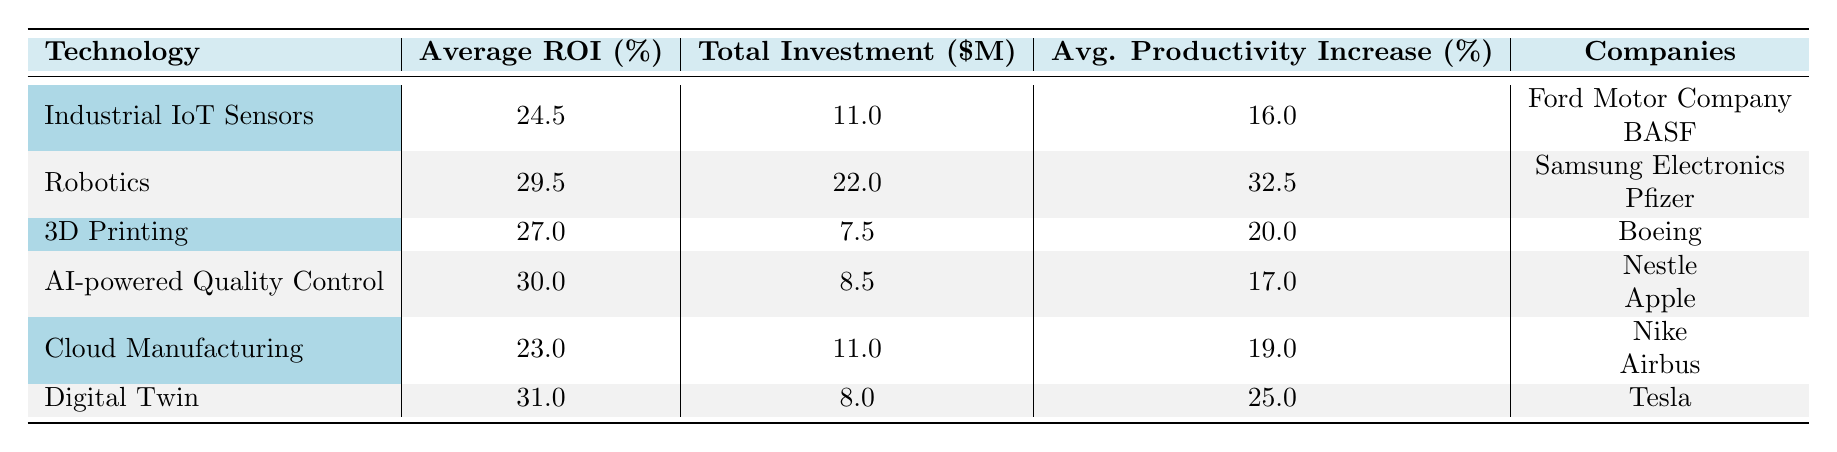What is the average ROI for Digital Twin technology? The average ROI for Digital Twin technology, as indicated in the table, is listed as 31.0%.
Answer: 31.0% Which company invested the most in Robotics? In the table, it is shown that Pfizer invested 12,000,000 in Robotics, which is greater than Samsung Electronics' investment of 10,000,000.
Answer: Pfizer What is the total investment across all technologies listed in the table? To calculate the total investment, sum the investments: 5,000,000 + 10,000,000 + 7,500,000 + 3,000,000 + 4,000,000 + 8,000,000 + 6,000,000 + 12,000,000 + 5,500,000 + 7,000,000 = 68,000,000.
Answer: 68,000,000 Is the average productivity increase for AI-powered Quality Control higher than that for Cloud Manufacturing? The average productivity increase for AI-powered Quality Control is 17.0%, while for Cloud Manufacturing it is 19.0%. Since 17.0% is less than 19.0%, the statement is false.
Answer: No What is the difference in the average ROI between Robotics and Cloud Manufacturing? The average ROI for Robotics is 29.5% and for Cloud Manufacturing is 23.0%. The difference can be calculated as 29.5% - 23.0% = 6.5%.
Answer: 6.5% 